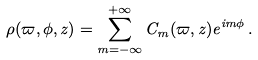<formula> <loc_0><loc_0><loc_500><loc_500>\rho ( \varpi , \phi , z ) = \sum _ { m = - \infty } ^ { + \infty } C _ { m } ( \varpi , z ) e ^ { i m \phi } \, .</formula> 